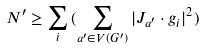Convert formula to latex. <formula><loc_0><loc_0><loc_500><loc_500>N ^ { \prime } \geq \sum _ { i } { ( \sum _ { a ^ { \prime } \in V ( G ^ { \prime } ) } { | J _ { a ^ { \prime } } \cdot g _ { i } | ^ { 2 } } ) }</formula> 